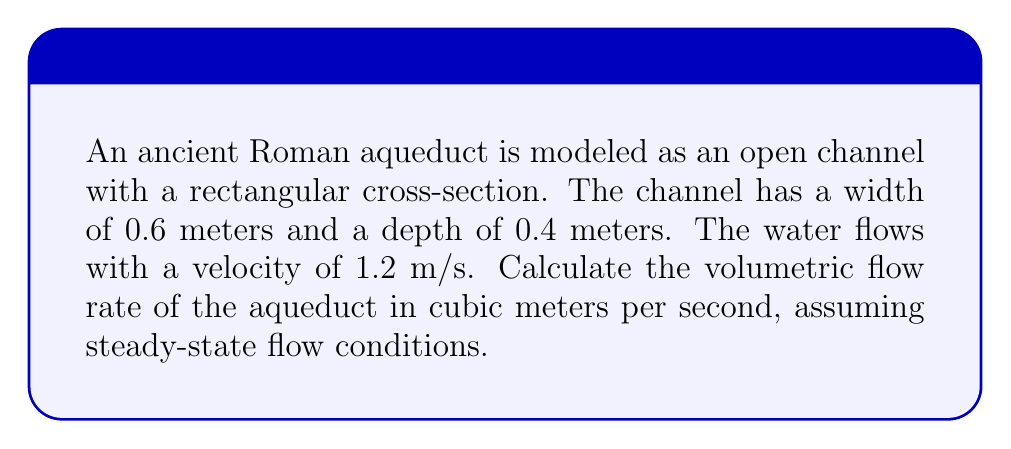Can you solve this math problem? To solve this problem, we'll use the continuity equation for incompressible fluid flow in a steady-state condition. The volumetric flow rate Q is given by the product of the cross-sectional area A and the fluid velocity v:

$$ Q = A \cdot v $$

Steps to solve:

1. Calculate the cross-sectional area A:
   $$ A = \text{width} \cdot \text{depth} = 0.6 \text{ m} \cdot 0.4 \text{ m} = 0.24 \text{ m}^2 $$

2. Use the given velocity:
   $$ v = 1.2 \text{ m/s} $$

3. Apply the continuity equation:
   $$ Q = A \cdot v = 0.24 \text{ m}^2 \cdot 1.2 \text{ m/s} = 0.288 \text{ m}^3/\text{s} $$

This calculation assumes ideal conditions and doesn't account for factors like friction or turbulence, which an experimental physicist might consider in a more detailed analysis of ancient water systems.
Answer: $0.288 \text{ m}^3/\text{s}$ 